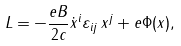<formula> <loc_0><loc_0><loc_500><loc_500>L = - \frac { e B } { 2 c } \dot { x } ^ { i } \varepsilon _ { i j } \, x ^ { j } + e \Phi ( x ) ,</formula> 